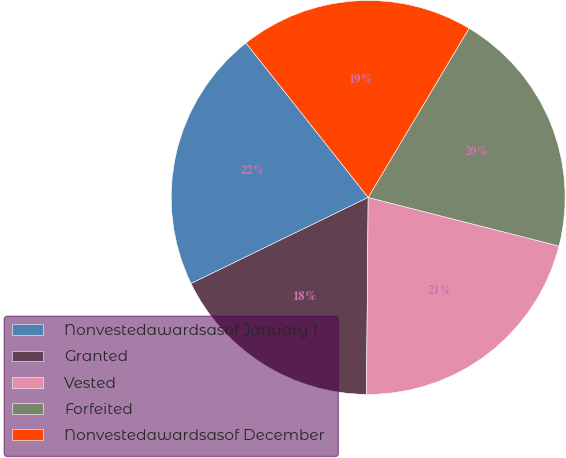Convert chart to OTSL. <chart><loc_0><loc_0><loc_500><loc_500><pie_chart><fcel>Nonvestedawardsasof January 1<fcel>Granted<fcel>Vested<fcel>Forfeited<fcel>Nonvestedawardsasof December<nl><fcel>21.55%<fcel>17.66%<fcel>21.17%<fcel>20.41%<fcel>19.21%<nl></chart> 